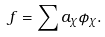<formula> <loc_0><loc_0><loc_500><loc_500>f = \sum a _ { \chi } \phi _ { \chi } .</formula> 